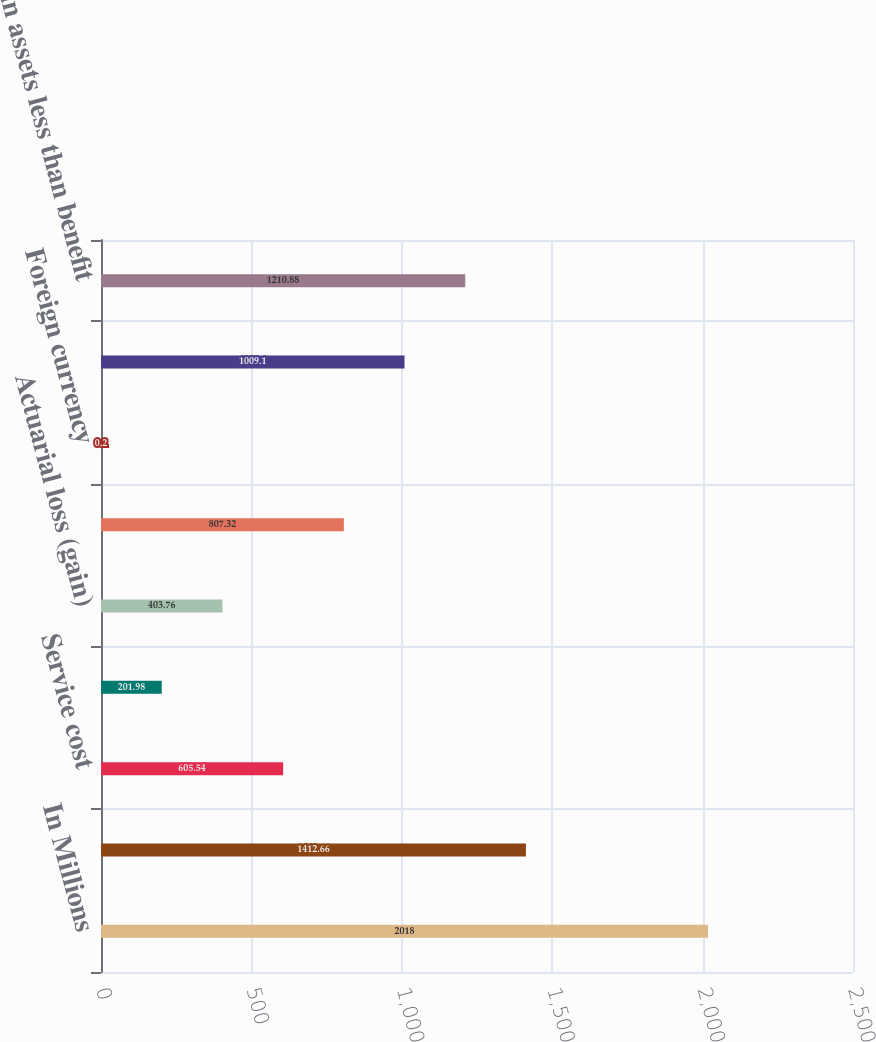<chart> <loc_0><loc_0><loc_500><loc_500><bar_chart><fcel>In Millions<fcel>Benefit obligation at<fcel>Service cost<fcel>Interest cost<fcel>Actuarial loss (gain)<fcel>Benefits payments<fcel>Foreign currency<fcel>Projected benefit obligation<fcel>Plan assets less than benefit<nl><fcel>2018<fcel>1412.66<fcel>605.54<fcel>201.98<fcel>403.76<fcel>807.32<fcel>0.2<fcel>1009.1<fcel>1210.88<nl></chart> 